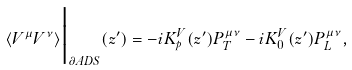<formula> <loc_0><loc_0><loc_500><loc_500>\langle V ^ { \mu } V ^ { \nu } \rangle \Big | _ { \partial A D S } ( z ^ { \prime } ) = - i K ^ { V } _ { p } ( z ^ { \prime } ) P _ { T } ^ { \mu \nu } - i K ^ { V } _ { 0 } ( z ^ { \prime } ) P _ { L } ^ { \mu \nu } ,</formula> 